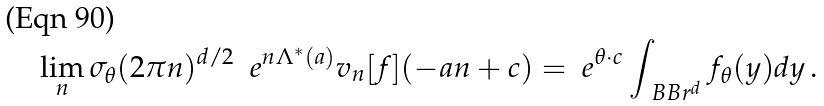<formula> <loc_0><loc_0><loc_500><loc_500>\lim _ { n } \sigma _ { \theta } ( 2 \pi n ) ^ { d / 2 } \ \ e ^ { n \Lambda ^ { * } ( a ) } v _ { n } [ f ] ( - a n + c ) = \ e ^ { \theta \cdot c } \int _ { \ B B r ^ { d } } f _ { \theta } ( y ) d y \, .</formula> 